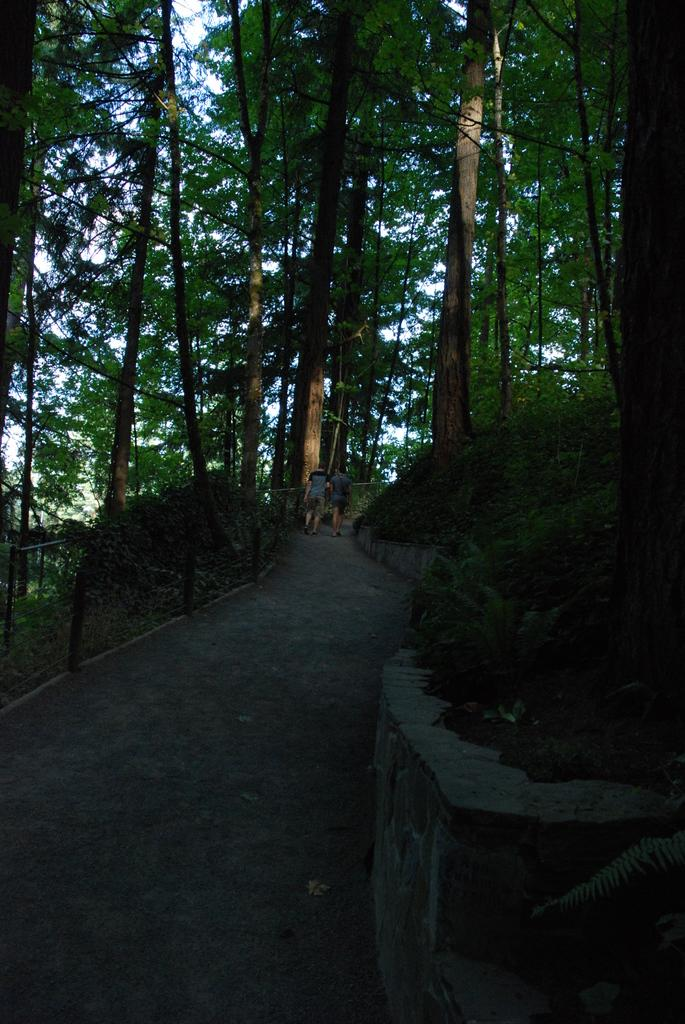Where was the image taken? The image was clicked outside the city. What is happening in the center of the image? There are two persons in the center of the image. What are the persons doing in the image? The persons appear to be walking on the ground. What can be seen in the background of the image? There are trees, plants, and the sky visible in the background of the image. What type of cake is being served at the mass in the image? There is no cake or mass present in the image; it features two persons walking outside the city with trees and the sky in the background. 